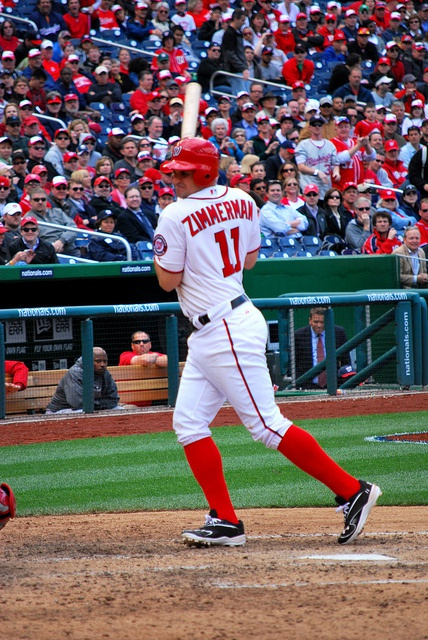Describe the objects in this image and their specific colors. I can see people in brown, black, gray, and navy tones, people in brown and lavender tones, bench in brown, gray, maroon, and black tones, people in brown, gray, black, and darkgray tones, and people in brown and lightblue tones in this image. 